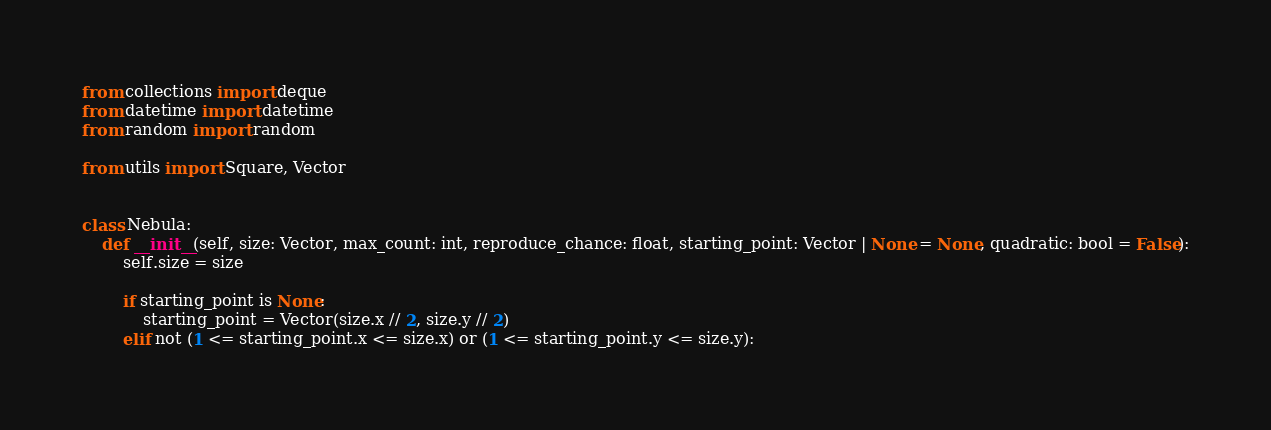Convert code to text. <code><loc_0><loc_0><loc_500><loc_500><_Python_>from collections import deque
from datetime import datetime
from random import random

from utils import Square, Vector


class Nebula:
    def __init__(self, size: Vector, max_count: int, reproduce_chance: float, starting_point: Vector | None = None, quadratic: bool = False):
        self.size = size

        if starting_point is None:
            starting_point = Vector(size.x // 2, size.y // 2)
        elif not (1 <= starting_point.x <= size.x) or (1 <= starting_point.y <= size.y):</code> 